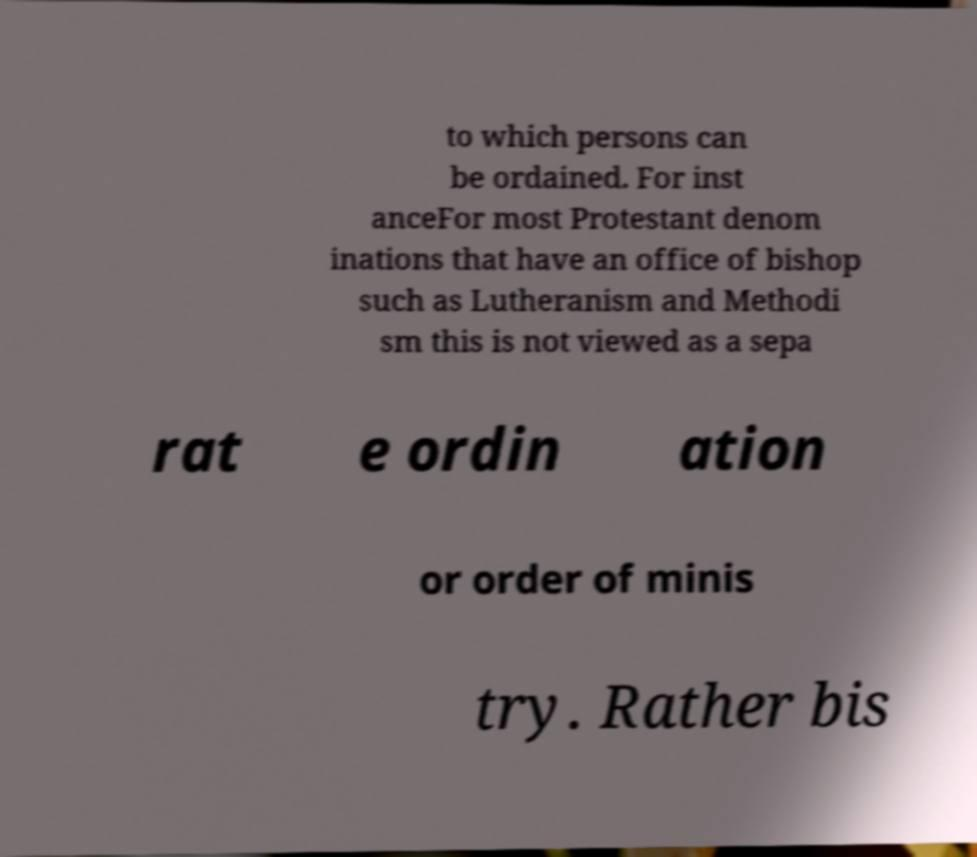For documentation purposes, I need the text within this image transcribed. Could you provide that? to which persons can be ordained. For inst anceFor most Protestant denom inations that have an office of bishop such as Lutheranism and Methodi sm this is not viewed as a sepa rat e ordin ation or order of minis try. Rather bis 